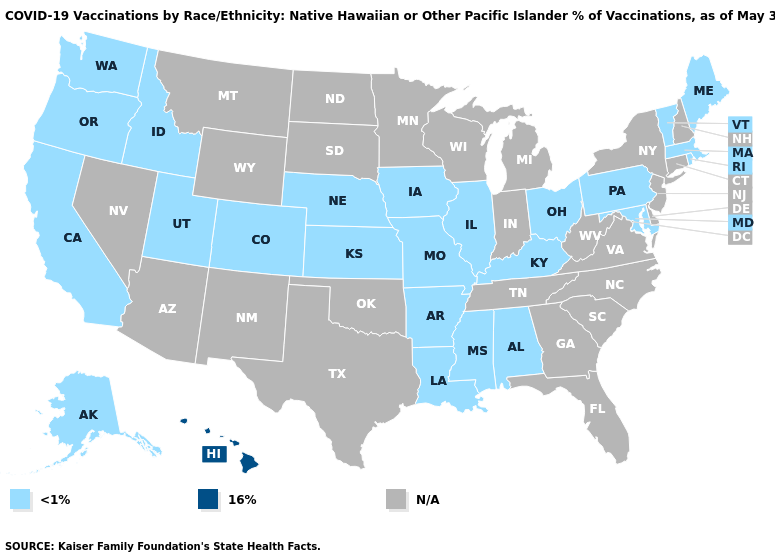What is the value of Tennessee?
Write a very short answer. N/A. Among the states that border South Dakota , which have the lowest value?
Write a very short answer. Iowa, Nebraska. What is the value of Florida?
Write a very short answer. N/A. Is the legend a continuous bar?
Concise answer only. No. What is the lowest value in states that border Connecticut?
Quick response, please. <1%. What is the value of Alaska?
Write a very short answer. <1%. Name the states that have a value in the range 16%?
Short answer required. Hawaii. Name the states that have a value in the range N/A?
Answer briefly. Arizona, Connecticut, Delaware, Florida, Georgia, Indiana, Michigan, Minnesota, Montana, Nevada, New Hampshire, New Jersey, New Mexico, New York, North Carolina, North Dakota, Oklahoma, South Carolina, South Dakota, Tennessee, Texas, Virginia, West Virginia, Wisconsin, Wyoming. What is the value of Connecticut?
Keep it brief. N/A. Does Hawaii have the highest value in the USA?
Short answer required. Yes. Name the states that have a value in the range 16%?
Short answer required. Hawaii. What is the lowest value in states that border Minnesota?
Short answer required. <1%. What is the value of Georgia?
Write a very short answer. N/A. 